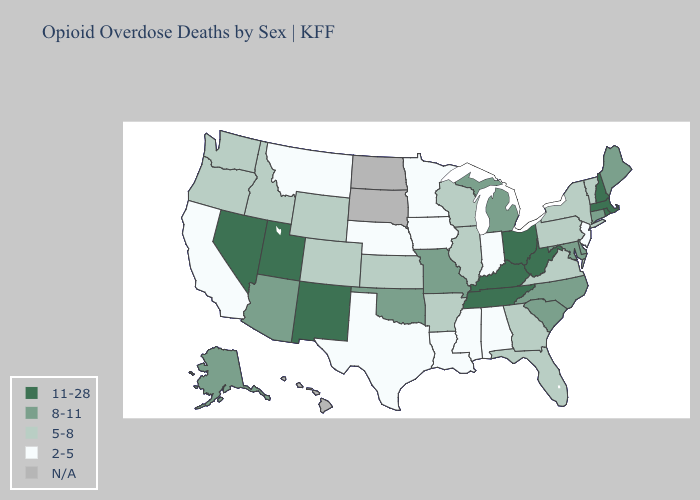Does the map have missing data?
Short answer required. Yes. Name the states that have a value in the range 5-8?
Be succinct. Arkansas, Colorado, Florida, Georgia, Idaho, Illinois, Kansas, New York, Oregon, Pennsylvania, Vermont, Virginia, Washington, Wisconsin, Wyoming. What is the highest value in states that border Kentucky?
Answer briefly. 11-28. What is the value of Washington?
Short answer required. 5-8. Does the first symbol in the legend represent the smallest category?
Keep it brief. No. What is the value of New Jersey?
Be succinct. 2-5. Name the states that have a value in the range 2-5?
Concise answer only. Alabama, California, Indiana, Iowa, Louisiana, Minnesota, Mississippi, Montana, Nebraska, New Jersey, Texas. What is the value of West Virginia?
Be succinct. 11-28. Name the states that have a value in the range 5-8?
Quick response, please. Arkansas, Colorado, Florida, Georgia, Idaho, Illinois, Kansas, New York, Oregon, Pennsylvania, Vermont, Virginia, Washington, Wisconsin, Wyoming. Does New Jersey have the lowest value in the USA?
Keep it brief. Yes. What is the value of Ohio?
Keep it brief. 11-28. Among the states that border Kansas , does Missouri have the highest value?
Short answer required. Yes. What is the lowest value in the USA?
Quick response, please. 2-5. Does Kentucky have the highest value in the South?
Be succinct. Yes. 